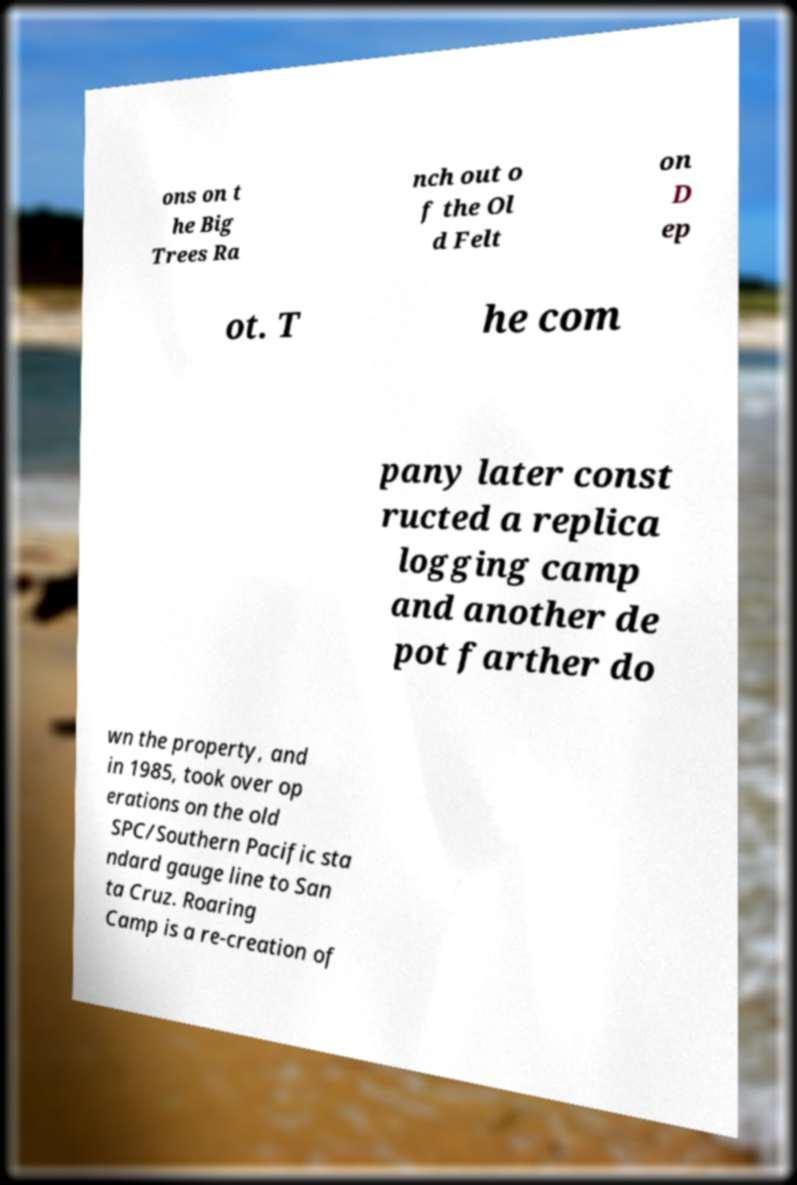I need the written content from this picture converted into text. Can you do that? ons on t he Big Trees Ra nch out o f the Ol d Felt on D ep ot. T he com pany later const ructed a replica logging camp and another de pot farther do wn the property, and in 1985, took over op erations on the old SPC/Southern Pacific sta ndard gauge line to San ta Cruz. Roaring Camp is a re-creation of 